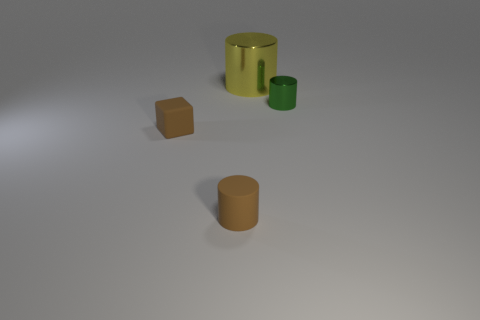Subtract all gray cubes. Subtract all gray cylinders. How many cubes are left? 1 Add 4 metal blocks. How many objects exist? 8 Subtract all cubes. How many objects are left? 3 Subtract 0 blue blocks. How many objects are left? 4 Subtract all large green blocks. Subtract all brown cylinders. How many objects are left? 3 Add 3 large metal things. How many large metal things are left? 4 Add 1 tiny green shiny cylinders. How many tiny green shiny cylinders exist? 2 